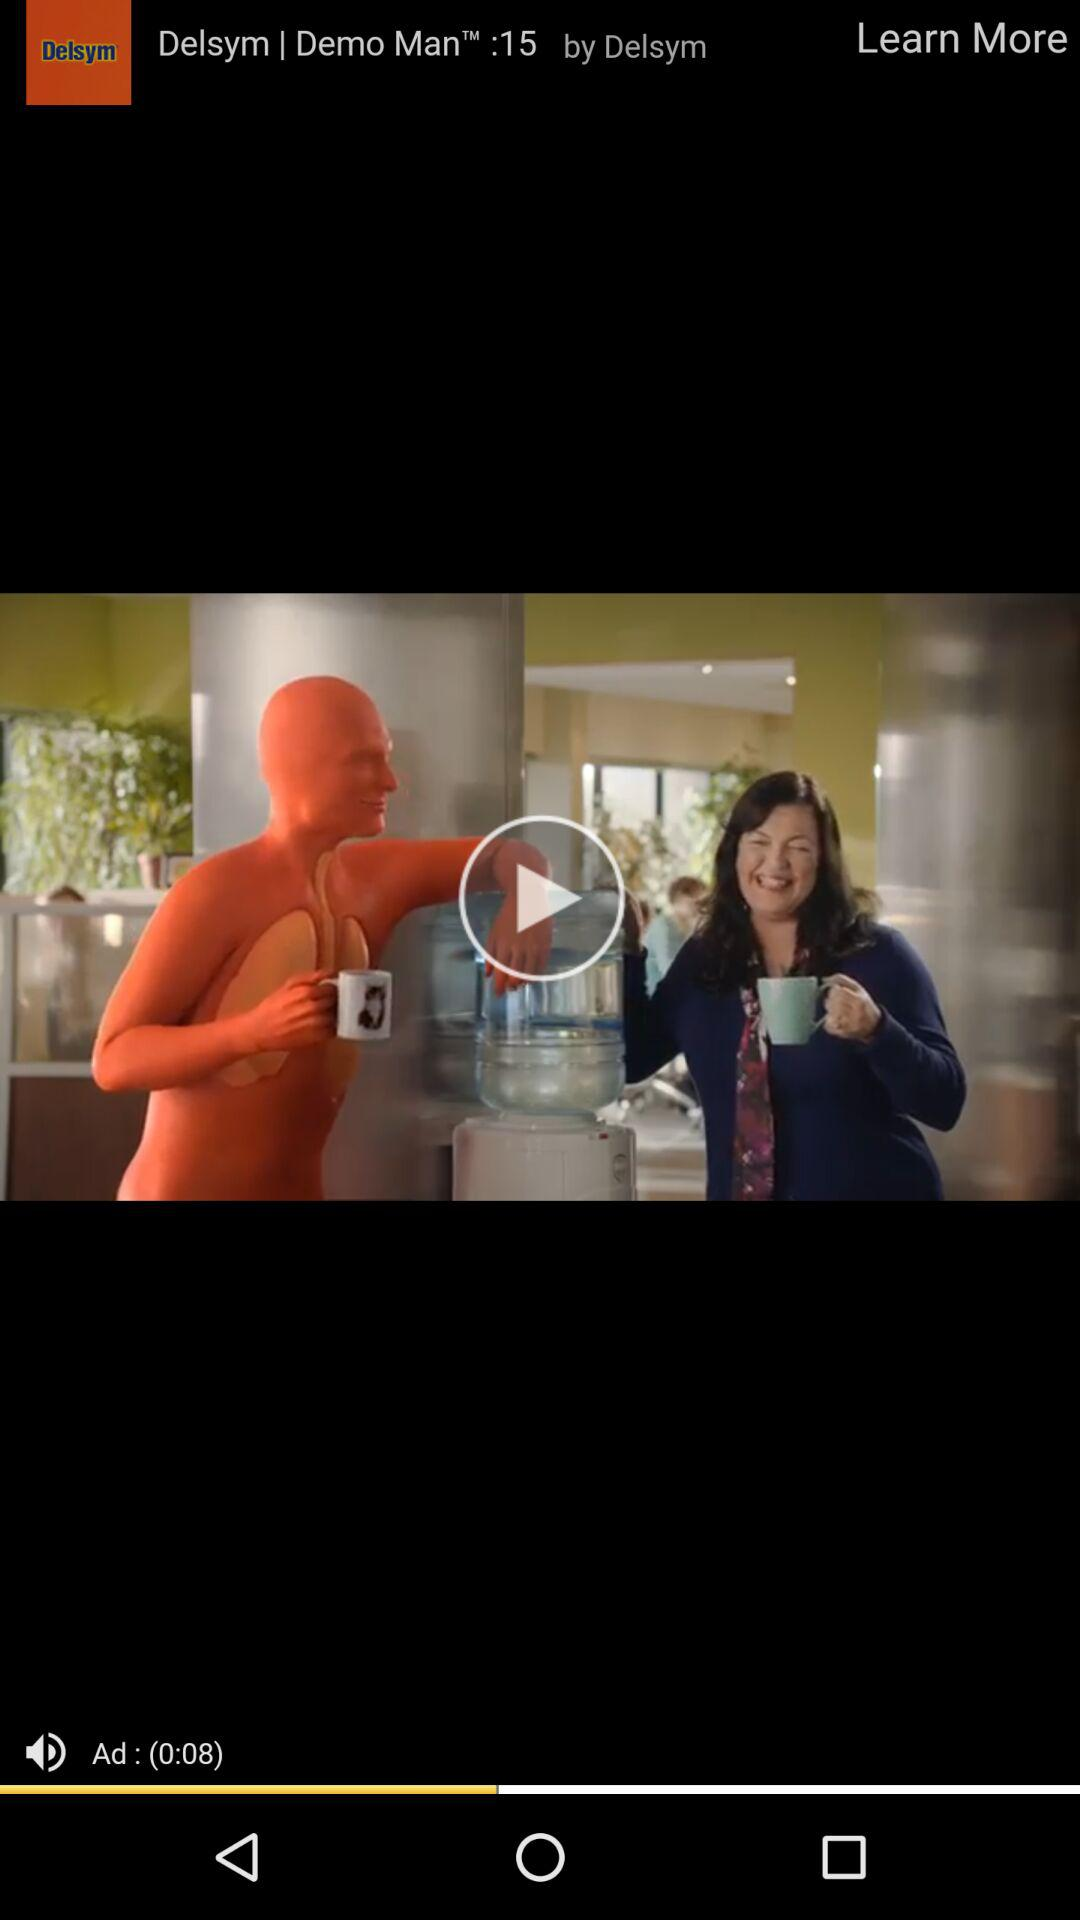How many seconds long is the ad?
Answer the question using a single word or phrase. 8 